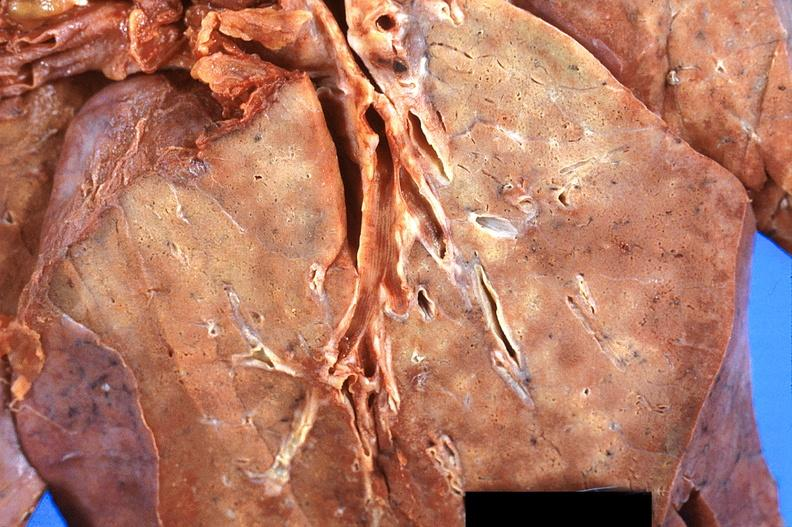where is this?
Answer the question using a single word or phrase. Lung 